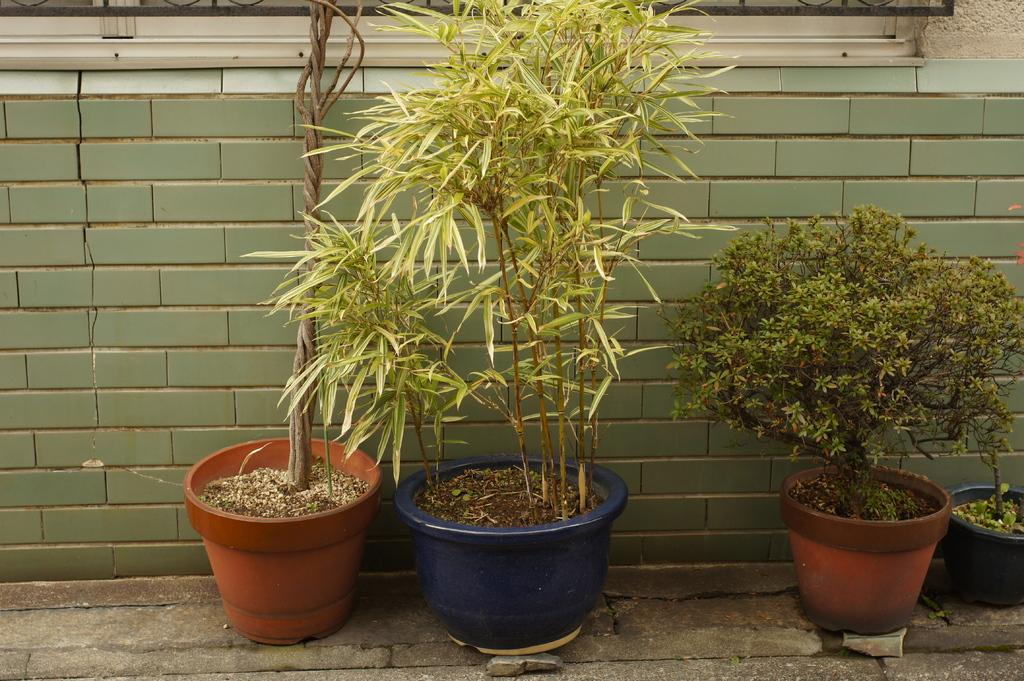What type of objects are present with the plants in the image? The plants are in pots in the image. Where are the plants located in the image? The plants are on a path in the image. What can be seen in the background of the image? There is a wall in the background of the image. What is visible at the top of the image? There is a grille and a glass object at the top of the image, as well as a wall. What type of insurance policy is being discussed by the plants in the image? There are no plants or discussions in the image, so it is not possible to determine what type of insurance policy might be discussed. 